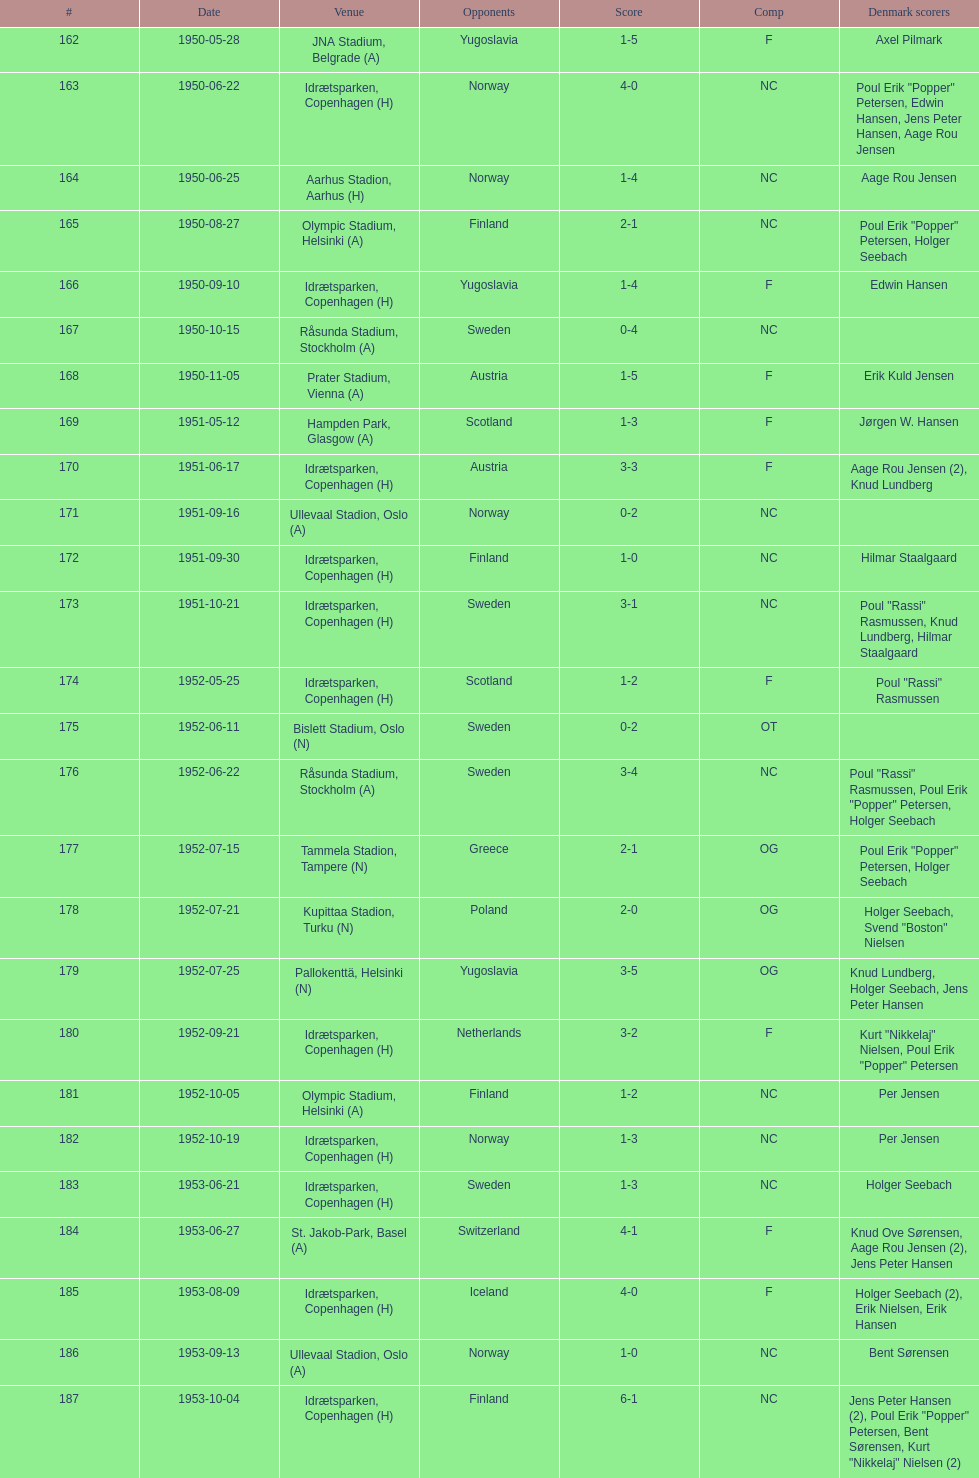Which game had a higher total score, #163 or #181? 163. 